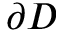<formula> <loc_0><loc_0><loc_500><loc_500>\partial D</formula> 